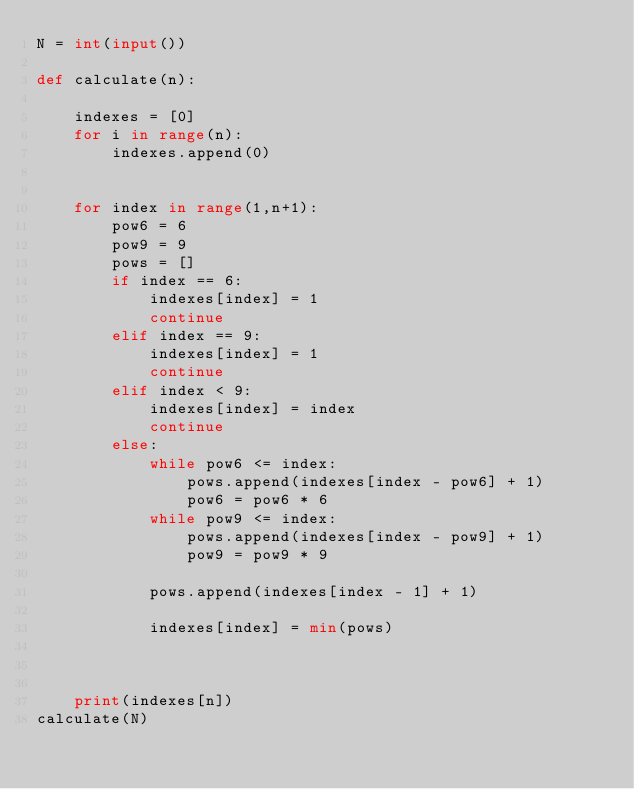<code> <loc_0><loc_0><loc_500><loc_500><_Python_>N = int(input())

def calculate(n):

    indexes = [0]
    for i in range(n):
        indexes.append(0)


    for index in range(1,n+1):
        pow6 = 6
        pow9 = 9
        pows = []
        if index == 6:
            indexes[index] = 1
            continue
        elif index == 9:
            indexes[index] = 1
            continue
        elif index < 9:
            indexes[index] = index
            continue
        else:
            while pow6 <= index:
                pows.append(indexes[index - pow6] + 1)
                pow6 = pow6 * 6
            while pow9 <= index:
                pows.append(indexes[index - pow9] + 1)
                pow9 = pow9 * 9

            pows.append(indexes[index - 1] + 1)

            indexes[index] = min(pows)



    print(indexes[n])
calculate(N)</code> 